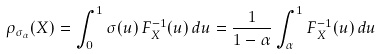Convert formula to latex. <formula><loc_0><loc_0><loc_500><loc_500>\rho _ { \sigma _ { \alpha } } ( X ) = \int _ { 0 } ^ { 1 } \sigma ( u ) \, F _ { X } ^ { - 1 } ( u ) \, d u = \frac { 1 } { 1 - \alpha } \int _ { \alpha } ^ { 1 } F _ { X } ^ { - 1 } ( u ) \, d u</formula> 